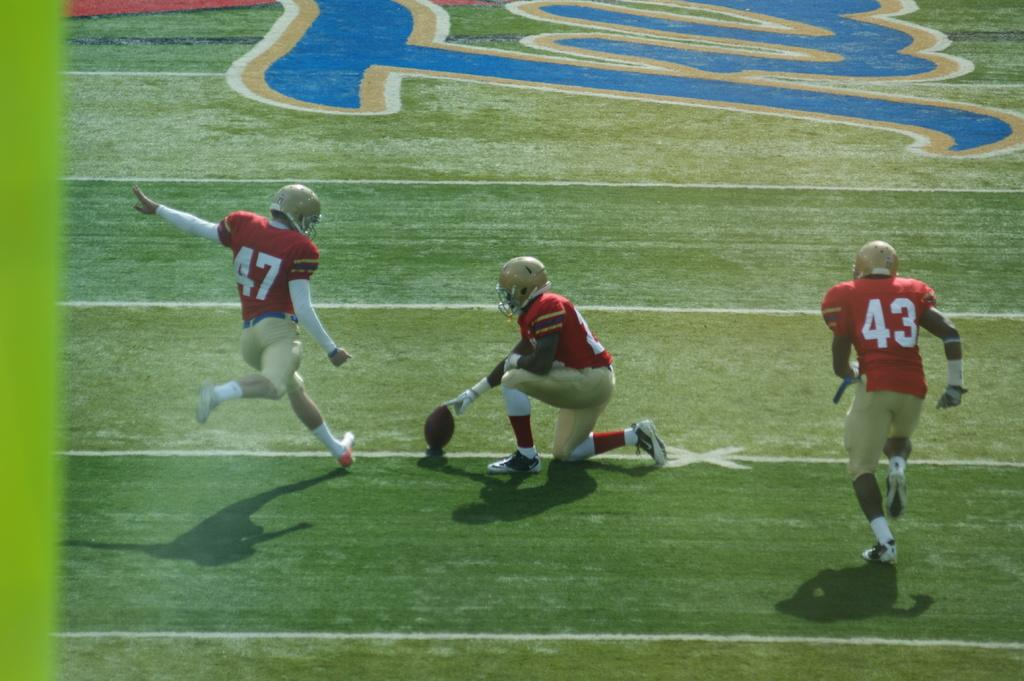What sport are the players in the image participating in? The players are playing football. Where is the football game taking place? The football game is taking place on the ground. Can you describe the players' actions in the image? The players are actively engaged in playing football. What type of hill can be seen in the background of the image? There is no hill visible in the image; it features players playing football on the ground. 